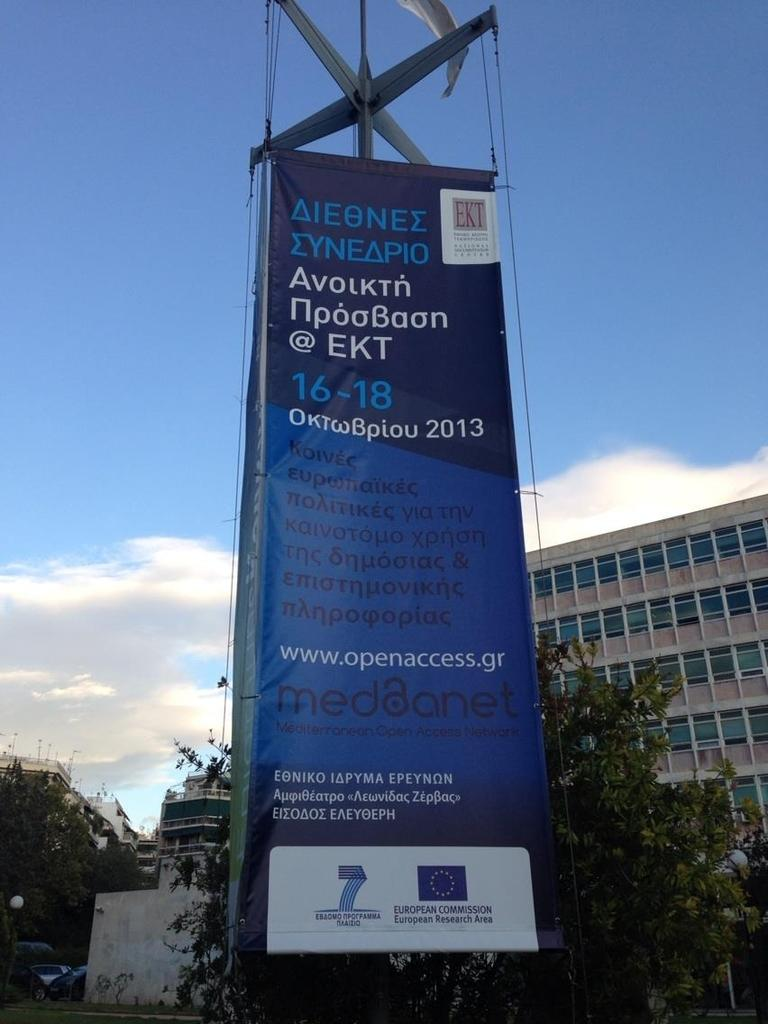<image>
Create a compact narrative representing the image presented. A russian sign with EKT in the upper right corner. 